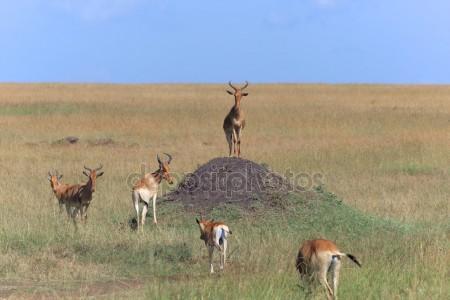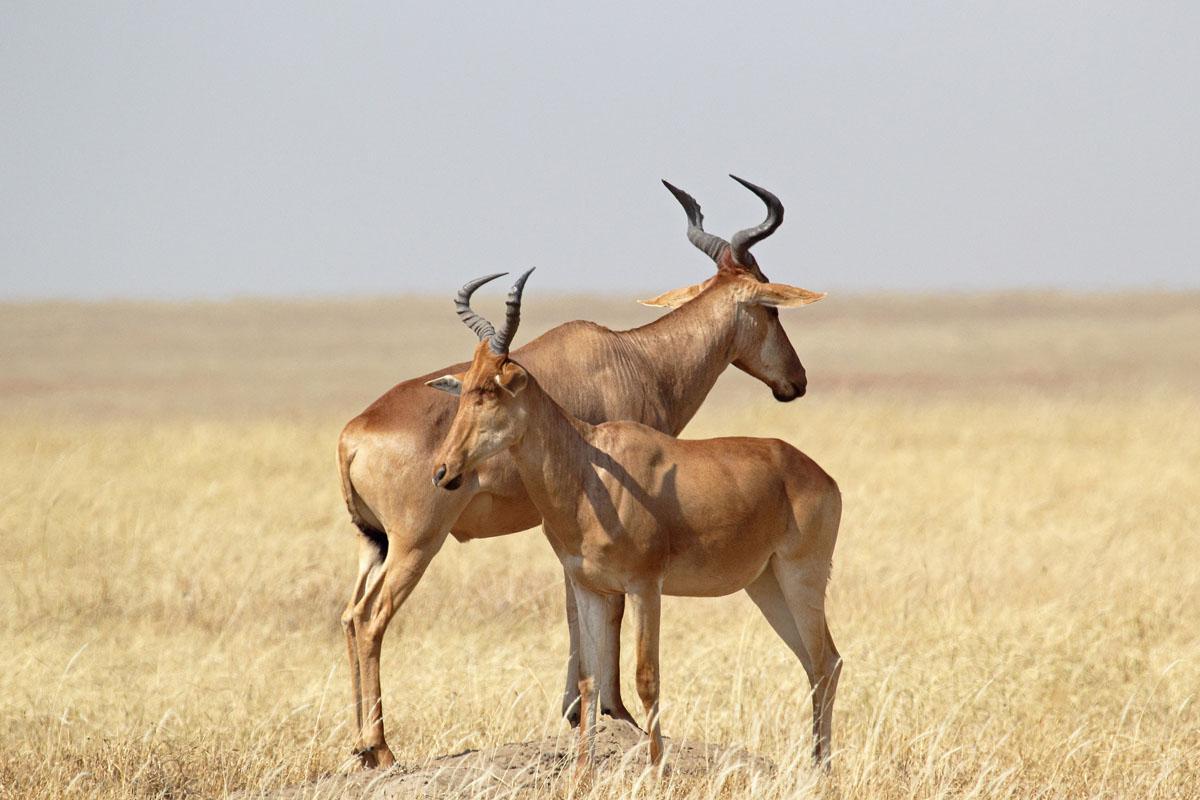The first image is the image on the left, the second image is the image on the right. For the images shown, is this caption "There are baby antelope in the image on the left." true? Answer yes or no. No. The first image is the image on the left, the second image is the image on the right. Given the left and right images, does the statement "One of the images includes a single animal." hold true? Answer yes or no. No. 